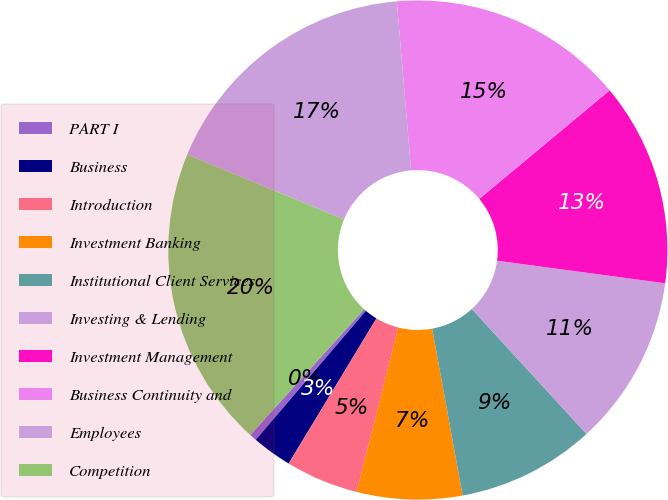Convert chart to OTSL. <chart><loc_0><loc_0><loc_500><loc_500><pie_chart><fcel>PART I<fcel>Business<fcel>Introduction<fcel>Investment Banking<fcel>Institutional Client Services<fcel>Investing & Lending<fcel>Investment Management<fcel>Business Continuity and<fcel>Employees<fcel>Competition<nl><fcel>0.47%<fcel>2.59%<fcel>4.71%<fcel>6.82%<fcel>8.94%<fcel>11.06%<fcel>13.18%<fcel>15.29%<fcel>17.41%<fcel>19.53%<nl></chart> 